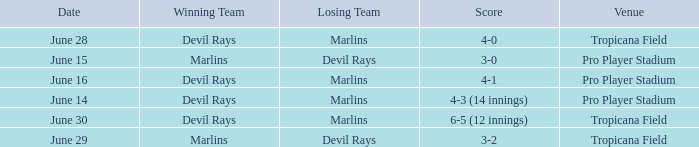What was the score on june 29 when the devil rays los? 3-2. 